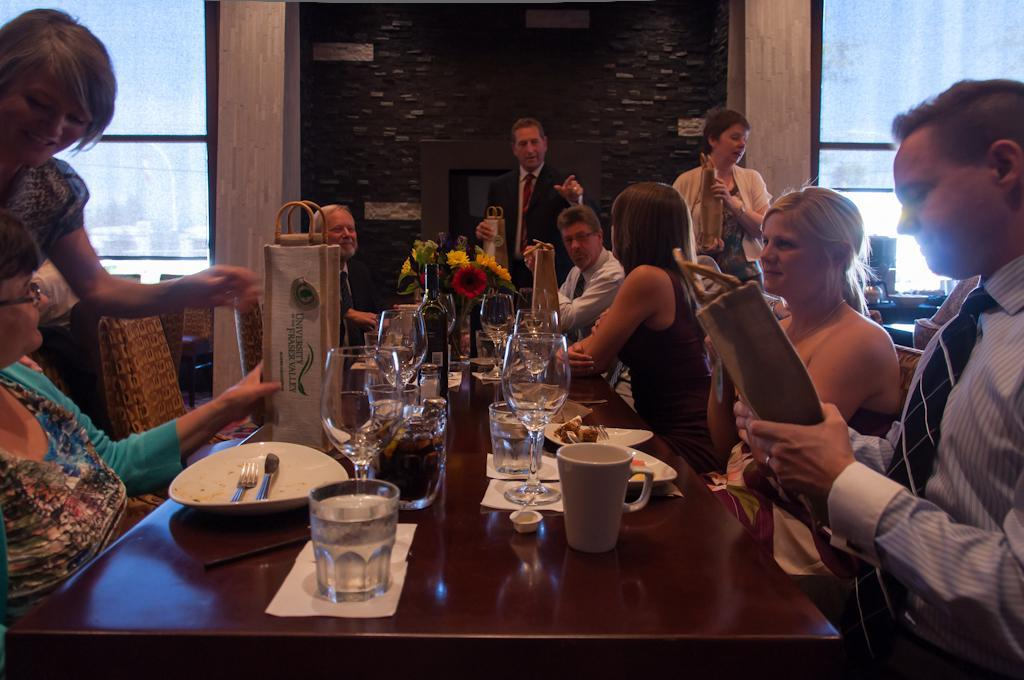What is the main subject of the image? The main subject of the image is a group of people. What are some of the people in the group doing? Some people in the group are sitting, while others are standing. What type of brick is being used to build the tank in the image? There is no brick or tank present in the image; it features a group of people with some sitting and others standing. 